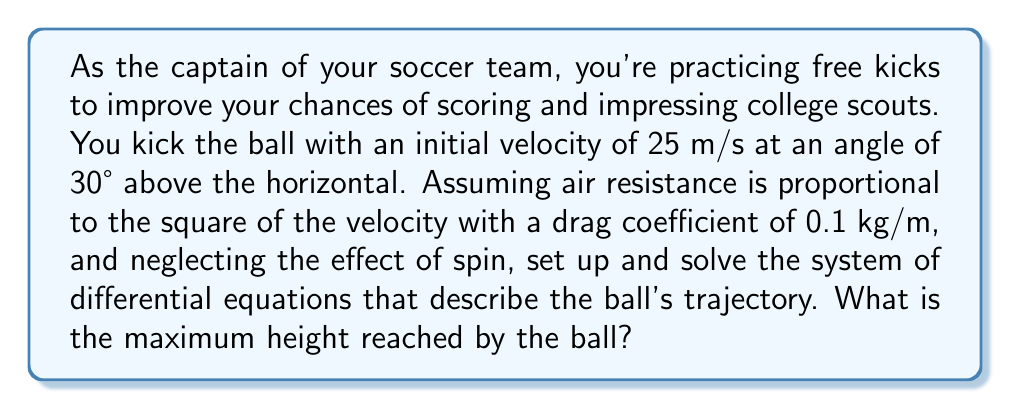Can you solve this math problem? Let's approach this step-by-step:

1) First, we need to set up our differential equations. Let $x$ and $y$ represent the horizontal and vertical positions of the ball, respectively. The equations of motion are:

   $$m\frac{d^2x}{dt^2} = -kv\frac{dx}{dt}$$
   $$m\frac{d^2y}{dt^2} = -mg - kv\frac{dy}{dt}$$

   where $m$ is the mass of the ball, $g$ is the acceleration due to gravity (9.8 m/s²), $k$ is the drag coefficient (0.1 kg/m), and $v$ is the velocity.

2) The velocity $v$ is given by:

   $$v = \sqrt{(\frac{dx}{dt})^2 + (\frac{dy}{dt})^2}$$

3) We can simplify by letting $u = \frac{dx}{dt}$ and $w = \frac{dy}{dt}$. Our system becomes:

   $$\frac{du}{dt} = -\frac{k}{m}\sqrt{u^2 + w^2}u$$
   $$\frac{dw}{dt} = -g - \frac{k}{m}\sqrt{u^2 + w^2}w$$

4) The initial conditions are:
   
   $$u(0) = 25\cos(30°) \approx 21.65 \text{ m/s}$$
   $$w(0) = 25\sin(30°) = 12.5 \text{ m/s}$$
   $$x(0) = 0, y(0) = 0$$

5) This system of nonlinear differential equations doesn't have a closed-form solution. We need to use numerical methods to solve it. Using a numerical solver (like Runge-Kutta method), we can obtain the trajectory of the ball.

6) To find the maximum height, we need to find the point where the vertical velocity ($w$) becomes zero. This occurs at approximately $t = 1.28$ seconds.

7) Using the numerical solution, we can find that at this time, the height of the ball is approximately 7.94 meters.
Answer: 7.94 meters 